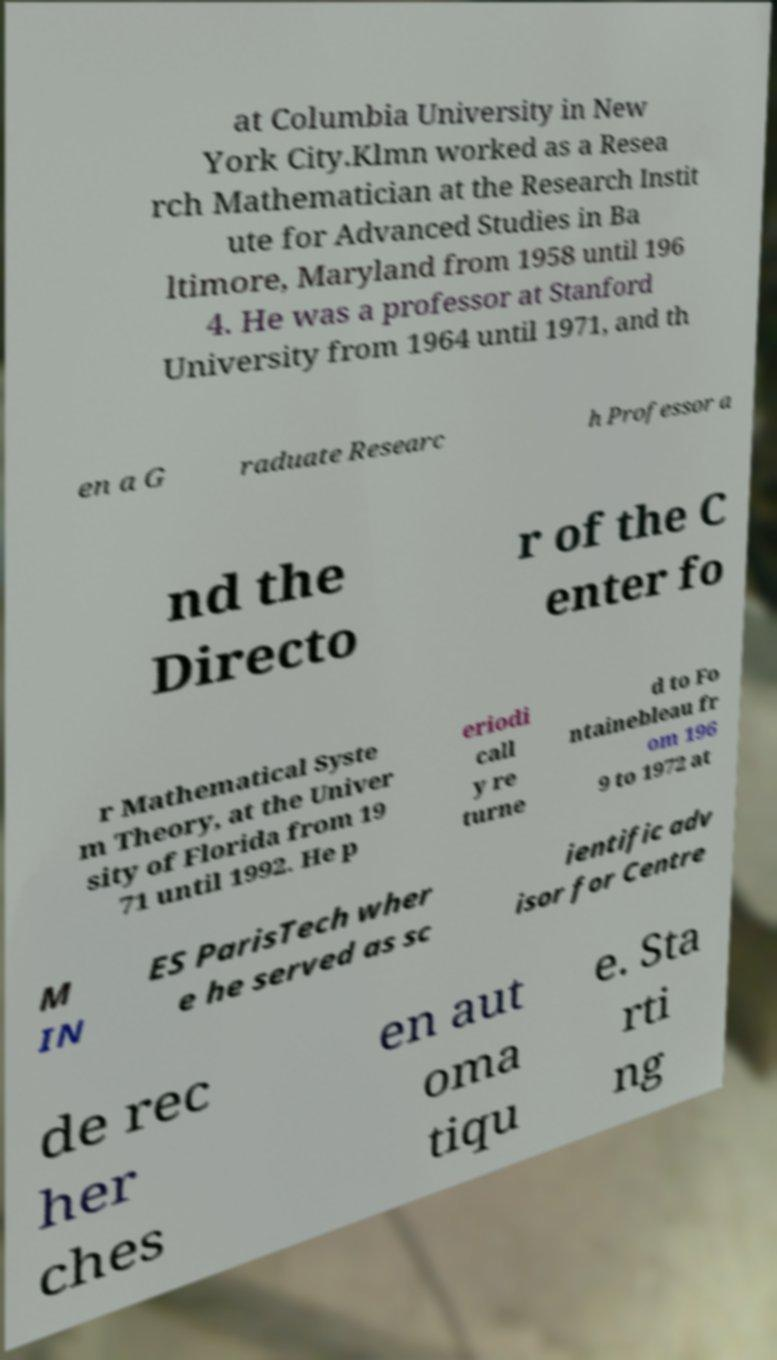Could you assist in decoding the text presented in this image and type it out clearly? at Columbia University in New York City.Klmn worked as a Resea rch Mathematician at the Research Instit ute for Advanced Studies in Ba ltimore, Maryland from 1958 until 196 4. He was a professor at Stanford University from 1964 until 1971, and th en a G raduate Researc h Professor a nd the Directo r of the C enter fo r Mathematical Syste m Theory, at the Univer sity of Florida from 19 71 until 1992. He p eriodi call y re turne d to Fo ntainebleau fr om 196 9 to 1972 at M IN ES ParisTech wher e he served as sc ientific adv isor for Centre de rec her ches en aut oma tiqu e. Sta rti ng 